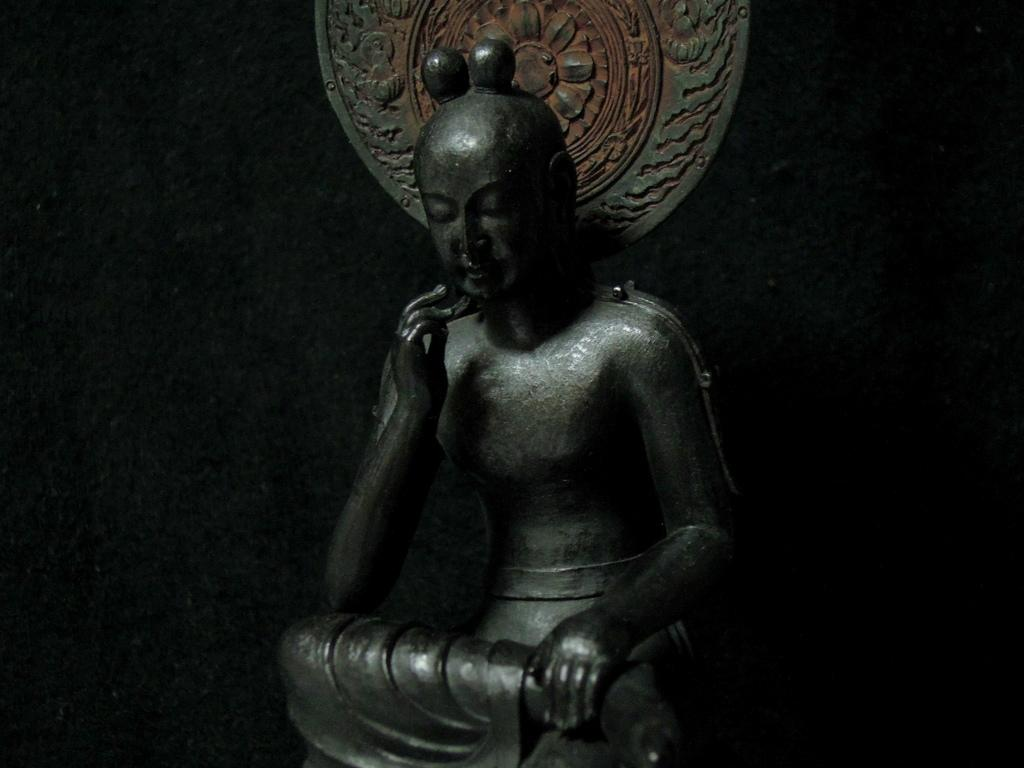What is the main subject of the image? There is a sculpture in the image. What can be observed about the background of the image? The background of the image is dark. What thoughts are the sculpture having in the image? Sculptures do not have thoughts, as they are inanimate objects. --- Facts: 1. There is a person holding a book in the image. 2. The person is sitting on a chair. 3. There is a table in front of the person. 4. The book has a red cover. Absurd Topics: dance, ocean, birdhouse Conversation: 